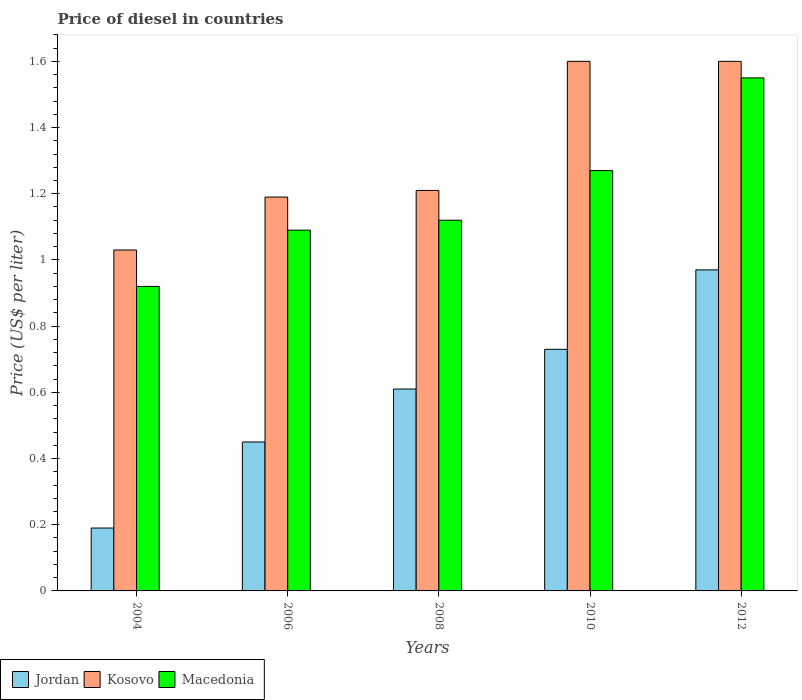How many different coloured bars are there?
Make the answer very short. 3. How many groups of bars are there?
Ensure brevity in your answer.  5. How many bars are there on the 5th tick from the right?
Offer a terse response. 3. In how many cases, is the number of bars for a given year not equal to the number of legend labels?
Offer a terse response. 0. Across all years, what is the maximum price of diesel in Kosovo?
Provide a short and direct response. 1.6. Across all years, what is the minimum price of diesel in Jordan?
Offer a terse response. 0.19. In which year was the price of diesel in Kosovo maximum?
Offer a very short reply. 2010. In which year was the price of diesel in Jordan minimum?
Provide a succinct answer. 2004. What is the total price of diesel in Kosovo in the graph?
Offer a very short reply. 6.63. What is the difference between the price of diesel in Macedonia in 2004 and that in 2008?
Keep it short and to the point. -0.2. What is the difference between the price of diesel in Jordan in 2006 and the price of diesel in Kosovo in 2004?
Provide a short and direct response. -0.58. What is the average price of diesel in Jordan per year?
Keep it short and to the point. 0.59. In the year 2012, what is the difference between the price of diesel in Jordan and price of diesel in Macedonia?
Provide a short and direct response. -0.58. What is the ratio of the price of diesel in Macedonia in 2006 to that in 2008?
Your answer should be compact. 0.97. Is the difference between the price of diesel in Jordan in 2010 and 2012 greater than the difference between the price of diesel in Macedonia in 2010 and 2012?
Provide a short and direct response. Yes. What is the difference between the highest and the second highest price of diesel in Macedonia?
Provide a short and direct response. 0.28. What is the difference between the highest and the lowest price of diesel in Macedonia?
Provide a succinct answer. 0.63. In how many years, is the price of diesel in Macedonia greater than the average price of diesel in Macedonia taken over all years?
Ensure brevity in your answer.  2. Is the sum of the price of diesel in Macedonia in 2006 and 2008 greater than the maximum price of diesel in Jordan across all years?
Provide a short and direct response. Yes. What does the 2nd bar from the left in 2008 represents?
Offer a terse response. Kosovo. What does the 2nd bar from the right in 2010 represents?
Provide a succinct answer. Kosovo. How many years are there in the graph?
Your response must be concise. 5. What is the difference between two consecutive major ticks on the Y-axis?
Ensure brevity in your answer.  0.2. Does the graph contain any zero values?
Your answer should be very brief. No. How are the legend labels stacked?
Offer a terse response. Horizontal. What is the title of the graph?
Provide a short and direct response. Price of diesel in countries. What is the label or title of the Y-axis?
Give a very brief answer. Price (US$ per liter). What is the Price (US$ per liter) in Jordan in 2004?
Make the answer very short. 0.19. What is the Price (US$ per liter) of Jordan in 2006?
Keep it short and to the point. 0.45. What is the Price (US$ per liter) of Kosovo in 2006?
Your answer should be compact. 1.19. What is the Price (US$ per liter) of Macedonia in 2006?
Your answer should be compact. 1.09. What is the Price (US$ per liter) in Jordan in 2008?
Give a very brief answer. 0.61. What is the Price (US$ per liter) of Kosovo in 2008?
Make the answer very short. 1.21. What is the Price (US$ per liter) of Macedonia in 2008?
Your answer should be compact. 1.12. What is the Price (US$ per liter) in Jordan in 2010?
Your answer should be compact. 0.73. What is the Price (US$ per liter) of Macedonia in 2010?
Offer a very short reply. 1.27. What is the Price (US$ per liter) of Jordan in 2012?
Give a very brief answer. 0.97. What is the Price (US$ per liter) in Kosovo in 2012?
Your response must be concise. 1.6. What is the Price (US$ per liter) of Macedonia in 2012?
Your response must be concise. 1.55. Across all years, what is the maximum Price (US$ per liter) of Macedonia?
Offer a terse response. 1.55. Across all years, what is the minimum Price (US$ per liter) in Jordan?
Provide a short and direct response. 0.19. Across all years, what is the minimum Price (US$ per liter) in Macedonia?
Ensure brevity in your answer.  0.92. What is the total Price (US$ per liter) in Jordan in the graph?
Keep it short and to the point. 2.95. What is the total Price (US$ per liter) of Kosovo in the graph?
Offer a very short reply. 6.63. What is the total Price (US$ per liter) of Macedonia in the graph?
Your answer should be compact. 5.95. What is the difference between the Price (US$ per liter) of Jordan in 2004 and that in 2006?
Offer a very short reply. -0.26. What is the difference between the Price (US$ per liter) in Kosovo in 2004 and that in 2006?
Your answer should be compact. -0.16. What is the difference between the Price (US$ per liter) in Macedonia in 2004 and that in 2006?
Provide a short and direct response. -0.17. What is the difference between the Price (US$ per liter) of Jordan in 2004 and that in 2008?
Provide a short and direct response. -0.42. What is the difference between the Price (US$ per liter) in Kosovo in 2004 and that in 2008?
Make the answer very short. -0.18. What is the difference between the Price (US$ per liter) of Macedonia in 2004 and that in 2008?
Make the answer very short. -0.2. What is the difference between the Price (US$ per liter) in Jordan in 2004 and that in 2010?
Provide a short and direct response. -0.54. What is the difference between the Price (US$ per liter) in Kosovo in 2004 and that in 2010?
Provide a succinct answer. -0.57. What is the difference between the Price (US$ per liter) in Macedonia in 2004 and that in 2010?
Your response must be concise. -0.35. What is the difference between the Price (US$ per liter) of Jordan in 2004 and that in 2012?
Offer a terse response. -0.78. What is the difference between the Price (US$ per liter) in Kosovo in 2004 and that in 2012?
Offer a terse response. -0.57. What is the difference between the Price (US$ per liter) in Macedonia in 2004 and that in 2012?
Your answer should be very brief. -0.63. What is the difference between the Price (US$ per liter) in Jordan in 2006 and that in 2008?
Keep it short and to the point. -0.16. What is the difference between the Price (US$ per liter) of Kosovo in 2006 and that in 2008?
Make the answer very short. -0.02. What is the difference between the Price (US$ per liter) in Macedonia in 2006 and that in 2008?
Your answer should be very brief. -0.03. What is the difference between the Price (US$ per liter) of Jordan in 2006 and that in 2010?
Provide a succinct answer. -0.28. What is the difference between the Price (US$ per liter) of Kosovo in 2006 and that in 2010?
Make the answer very short. -0.41. What is the difference between the Price (US$ per liter) in Macedonia in 2006 and that in 2010?
Make the answer very short. -0.18. What is the difference between the Price (US$ per liter) of Jordan in 2006 and that in 2012?
Your answer should be compact. -0.52. What is the difference between the Price (US$ per liter) in Kosovo in 2006 and that in 2012?
Offer a very short reply. -0.41. What is the difference between the Price (US$ per liter) of Macedonia in 2006 and that in 2012?
Give a very brief answer. -0.46. What is the difference between the Price (US$ per liter) in Jordan in 2008 and that in 2010?
Make the answer very short. -0.12. What is the difference between the Price (US$ per liter) of Kosovo in 2008 and that in 2010?
Give a very brief answer. -0.39. What is the difference between the Price (US$ per liter) of Macedonia in 2008 and that in 2010?
Keep it short and to the point. -0.15. What is the difference between the Price (US$ per liter) in Jordan in 2008 and that in 2012?
Your response must be concise. -0.36. What is the difference between the Price (US$ per liter) of Kosovo in 2008 and that in 2012?
Give a very brief answer. -0.39. What is the difference between the Price (US$ per liter) in Macedonia in 2008 and that in 2012?
Your response must be concise. -0.43. What is the difference between the Price (US$ per liter) in Jordan in 2010 and that in 2012?
Keep it short and to the point. -0.24. What is the difference between the Price (US$ per liter) of Kosovo in 2010 and that in 2012?
Keep it short and to the point. 0. What is the difference between the Price (US$ per liter) of Macedonia in 2010 and that in 2012?
Give a very brief answer. -0.28. What is the difference between the Price (US$ per liter) in Jordan in 2004 and the Price (US$ per liter) in Kosovo in 2006?
Provide a short and direct response. -1. What is the difference between the Price (US$ per liter) of Jordan in 2004 and the Price (US$ per liter) of Macedonia in 2006?
Provide a succinct answer. -0.9. What is the difference between the Price (US$ per liter) in Kosovo in 2004 and the Price (US$ per liter) in Macedonia in 2006?
Keep it short and to the point. -0.06. What is the difference between the Price (US$ per liter) in Jordan in 2004 and the Price (US$ per liter) in Kosovo in 2008?
Your answer should be compact. -1.02. What is the difference between the Price (US$ per liter) in Jordan in 2004 and the Price (US$ per liter) in Macedonia in 2008?
Ensure brevity in your answer.  -0.93. What is the difference between the Price (US$ per liter) in Kosovo in 2004 and the Price (US$ per liter) in Macedonia in 2008?
Provide a short and direct response. -0.09. What is the difference between the Price (US$ per liter) in Jordan in 2004 and the Price (US$ per liter) in Kosovo in 2010?
Provide a succinct answer. -1.41. What is the difference between the Price (US$ per liter) of Jordan in 2004 and the Price (US$ per liter) of Macedonia in 2010?
Give a very brief answer. -1.08. What is the difference between the Price (US$ per liter) in Kosovo in 2004 and the Price (US$ per liter) in Macedonia in 2010?
Offer a terse response. -0.24. What is the difference between the Price (US$ per liter) of Jordan in 2004 and the Price (US$ per liter) of Kosovo in 2012?
Provide a short and direct response. -1.41. What is the difference between the Price (US$ per liter) in Jordan in 2004 and the Price (US$ per liter) in Macedonia in 2012?
Your answer should be compact. -1.36. What is the difference between the Price (US$ per liter) in Kosovo in 2004 and the Price (US$ per liter) in Macedonia in 2012?
Your response must be concise. -0.52. What is the difference between the Price (US$ per liter) of Jordan in 2006 and the Price (US$ per liter) of Kosovo in 2008?
Ensure brevity in your answer.  -0.76. What is the difference between the Price (US$ per liter) in Jordan in 2006 and the Price (US$ per liter) in Macedonia in 2008?
Your answer should be very brief. -0.67. What is the difference between the Price (US$ per liter) in Kosovo in 2006 and the Price (US$ per liter) in Macedonia in 2008?
Make the answer very short. 0.07. What is the difference between the Price (US$ per liter) of Jordan in 2006 and the Price (US$ per liter) of Kosovo in 2010?
Offer a very short reply. -1.15. What is the difference between the Price (US$ per liter) in Jordan in 2006 and the Price (US$ per liter) in Macedonia in 2010?
Your answer should be very brief. -0.82. What is the difference between the Price (US$ per liter) of Kosovo in 2006 and the Price (US$ per liter) of Macedonia in 2010?
Give a very brief answer. -0.08. What is the difference between the Price (US$ per liter) in Jordan in 2006 and the Price (US$ per liter) in Kosovo in 2012?
Offer a terse response. -1.15. What is the difference between the Price (US$ per liter) in Jordan in 2006 and the Price (US$ per liter) in Macedonia in 2012?
Make the answer very short. -1.1. What is the difference between the Price (US$ per liter) of Kosovo in 2006 and the Price (US$ per liter) of Macedonia in 2012?
Make the answer very short. -0.36. What is the difference between the Price (US$ per liter) of Jordan in 2008 and the Price (US$ per liter) of Kosovo in 2010?
Your answer should be compact. -0.99. What is the difference between the Price (US$ per liter) in Jordan in 2008 and the Price (US$ per liter) in Macedonia in 2010?
Provide a short and direct response. -0.66. What is the difference between the Price (US$ per liter) of Kosovo in 2008 and the Price (US$ per liter) of Macedonia in 2010?
Keep it short and to the point. -0.06. What is the difference between the Price (US$ per liter) of Jordan in 2008 and the Price (US$ per liter) of Kosovo in 2012?
Keep it short and to the point. -0.99. What is the difference between the Price (US$ per liter) of Jordan in 2008 and the Price (US$ per liter) of Macedonia in 2012?
Your answer should be compact. -0.94. What is the difference between the Price (US$ per liter) in Kosovo in 2008 and the Price (US$ per liter) in Macedonia in 2012?
Provide a succinct answer. -0.34. What is the difference between the Price (US$ per liter) in Jordan in 2010 and the Price (US$ per liter) in Kosovo in 2012?
Ensure brevity in your answer.  -0.87. What is the difference between the Price (US$ per liter) in Jordan in 2010 and the Price (US$ per liter) in Macedonia in 2012?
Offer a very short reply. -0.82. What is the average Price (US$ per liter) of Jordan per year?
Offer a terse response. 0.59. What is the average Price (US$ per liter) of Kosovo per year?
Provide a short and direct response. 1.33. What is the average Price (US$ per liter) in Macedonia per year?
Provide a succinct answer. 1.19. In the year 2004, what is the difference between the Price (US$ per liter) in Jordan and Price (US$ per liter) in Kosovo?
Ensure brevity in your answer.  -0.84. In the year 2004, what is the difference between the Price (US$ per liter) in Jordan and Price (US$ per liter) in Macedonia?
Provide a succinct answer. -0.73. In the year 2004, what is the difference between the Price (US$ per liter) of Kosovo and Price (US$ per liter) of Macedonia?
Ensure brevity in your answer.  0.11. In the year 2006, what is the difference between the Price (US$ per liter) in Jordan and Price (US$ per liter) in Kosovo?
Your response must be concise. -0.74. In the year 2006, what is the difference between the Price (US$ per liter) in Jordan and Price (US$ per liter) in Macedonia?
Provide a succinct answer. -0.64. In the year 2008, what is the difference between the Price (US$ per liter) of Jordan and Price (US$ per liter) of Kosovo?
Make the answer very short. -0.6. In the year 2008, what is the difference between the Price (US$ per liter) in Jordan and Price (US$ per liter) in Macedonia?
Offer a very short reply. -0.51. In the year 2008, what is the difference between the Price (US$ per liter) in Kosovo and Price (US$ per liter) in Macedonia?
Provide a succinct answer. 0.09. In the year 2010, what is the difference between the Price (US$ per liter) in Jordan and Price (US$ per liter) in Kosovo?
Your answer should be compact. -0.87. In the year 2010, what is the difference between the Price (US$ per liter) in Jordan and Price (US$ per liter) in Macedonia?
Ensure brevity in your answer.  -0.54. In the year 2010, what is the difference between the Price (US$ per liter) of Kosovo and Price (US$ per liter) of Macedonia?
Keep it short and to the point. 0.33. In the year 2012, what is the difference between the Price (US$ per liter) in Jordan and Price (US$ per liter) in Kosovo?
Make the answer very short. -0.63. In the year 2012, what is the difference between the Price (US$ per liter) in Jordan and Price (US$ per liter) in Macedonia?
Your answer should be compact. -0.58. What is the ratio of the Price (US$ per liter) of Jordan in 2004 to that in 2006?
Offer a very short reply. 0.42. What is the ratio of the Price (US$ per liter) in Kosovo in 2004 to that in 2006?
Give a very brief answer. 0.87. What is the ratio of the Price (US$ per liter) in Macedonia in 2004 to that in 2006?
Offer a very short reply. 0.84. What is the ratio of the Price (US$ per liter) in Jordan in 2004 to that in 2008?
Your response must be concise. 0.31. What is the ratio of the Price (US$ per liter) in Kosovo in 2004 to that in 2008?
Provide a succinct answer. 0.85. What is the ratio of the Price (US$ per liter) of Macedonia in 2004 to that in 2008?
Your answer should be compact. 0.82. What is the ratio of the Price (US$ per liter) in Jordan in 2004 to that in 2010?
Your answer should be compact. 0.26. What is the ratio of the Price (US$ per liter) of Kosovo in 2004 to that in 2010?
Keep it short and to the point. 0.64. What is the ratio of the Price (US$ per liter) of Macedonia in 2004 to that in 2010?
Make the answer very short. 0.72. What is the ratio of the Price (US$ per liter) of Jordan in 2004 to that in 2012?
Provide a succinct answer. 0.2. What is the ratio of the Price (US$ per liter) of Kosovo in 2004 to that in 2012?
Ensure brevity in your answer.  0.64. What is the ratio of the Price (US$ per liter) in Macedonia in 2004 to that in 2012?
Make the answer very short. 0.59. What is the ratio of the Price (US$ per liter) in Jordan in 2006 to that in 2008?
Give a very brief answer. 0.74. What is the ratio of the Price (US$ per liter) of Kosovo in 2006 to that in 2008?
Your answer should be very brief. 0.98. What is the ratio of the Price (US$ per liter) in Macedonia in 2006 to that in 2008?
Provide a succinct answer. 0.97. What is the ratio of the Price (US$ per liter) of Jordan in 2006 to that in 2010?
Provide a succinct answer. 0.62. What is the ratio of the Price (US$ per liter) of Kosovo in 2006 to that in 2010?
Give a very brief answer. 0.74. What is the ratio of the Price (US$ per liter) of Macedonia in 2006 to that in 2010?
Your response must be concise. 0.86. What is the ratio of the Price (US$ per liter) of Jordan in 2006 to that in 2012?
Give a very brief answer. 0.46. What is the ratio of the Price (US$ per liter) in Kosovo in 2006 to that in 2012?
Ensure brevity in your answer.  0.74. What is the ratio of the Price (US$ per liter) of Macedonia in 2006 to that in 2012?
Ensure brevity in your answer.  0.7. What is the ratio of the Price (US$ per liter) of Jordan in 2008 to that in 2010?
Keep it short and to the point. 0.84. What is the ratio of the Price (US$ per liter) of Kosovo in 2008 to that in 2010?
Give a very brief answer. 0.76. What is the ratio of the Price (US$ per liter) in Macedonia in 2008 to that in 2010?
Provide a succinct answer. 0.88. What is the ratio of the Price (US$ per liter) in Jordan in 2008 to that in 2012?
Offer a very short reply. 0.63. What is the ratio of the Price (US$ per liter) of Kosovo in 2008 to that in 2012?
Provide a short and direct response. 0.76. What is the ratio of the Price (US$ per liter) in Macedonia in 2008 to that in 2012?
Provide a succinct answer. 0.72. What is the ratio of the Price (US$ per liter) of Jordan in 2010 to that in 2012?
Keep it short and to the point. 0.75. What is the ratio of the Price (US$ per liter) in Macedonia in 2010 to that in 2012?
Give a very brief answer. 0.82. What is the difference between the highest and the second highest Price (US$ per liter) in Jordan?
Ensure brevity in your answer.  0.24. What is the difference between the highest and the second highest Price (US$ per liter) of Kosovo?
Ensure brevity in your answer.  0. What is the difference between the highest and the second highest Price (US$ per liter) in Macedonia?
Make the answer very short. 0.28. What is the difference between the highest and the lowest Price (US$ per liter) in Jordan?
Provide a succinct answer. 0.78. What is the difference between the highest and the lowest Price (US$ per liter) of Kosovo?
Offer a terse response. 0.57. What is the difference between the highest and the lowest Price (US$ per liter) in Macedonia?
Offer a very short reply. 0.63. 